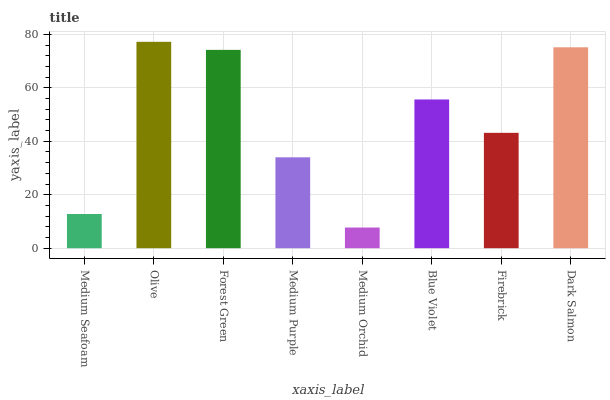Is Medium Orchid the minimum?
Answer yes or no. Yes. Is Olive the maximum?
Answer yes or no. Yes. Is Forest Green the minimum?
Answer yes or no. No. Is Forest Green the maximum?
Answer yes or no. No. Is Olive greater than Forest Green?
Answer yes or no. Yes. Is Forest Green less than Olive?
Answer yes or no. Yes. Is Forest Green greater than Olive?
Answer yes or no. No. Is Olive less than Forest Green?
Answer yes or no. No. Is Blue Violet the high median?
Answer yes or no. Yes. Is Firebrick the low median?
Answer yes or no. Yes. Is Forest Green the high median?
Answer yes or no. No. Is Dark Salmon the low median?
Answer yes or no. No. 